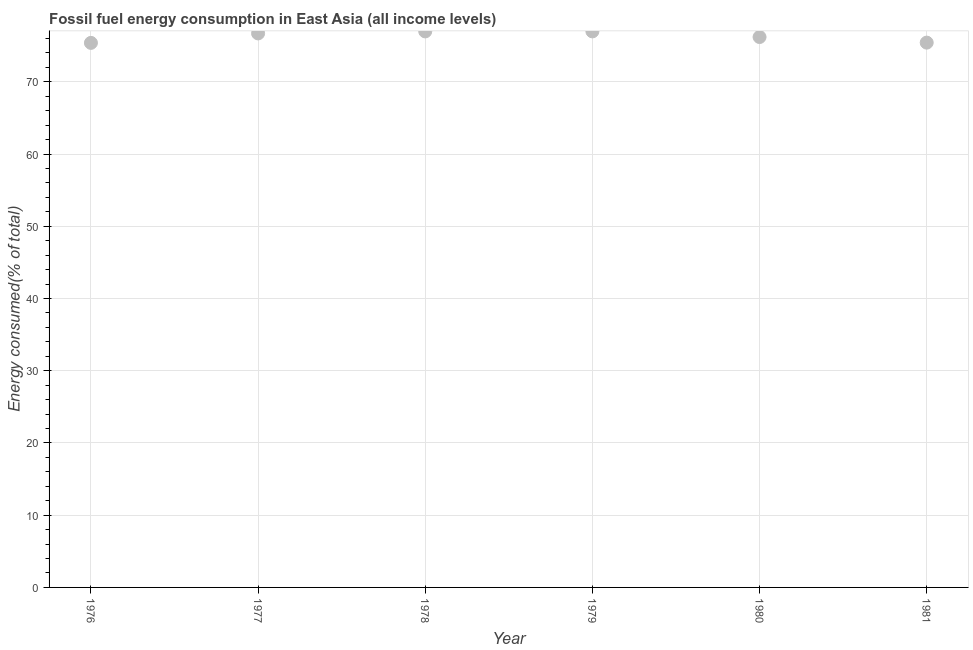What is the fossil fuel energy consumption in 1977?
Ensure brevity in your answer.  76.7. Across all years, what is the maximum fossil fuel energy consumption?
Ensure brevity in your answer.  76.98. Across all years, what is the minimum fossil fuel energy consumption?
Provide a succinct answer. 75.39. In which year was the fossil fuel energy consumption maximum?
Make the answer very short. 1979. In which year was the fossil fuel energy consumption minimum?
Your response must be concise. 1976. What is the sum of the fossil fuel energy consumption?
Give a very brief answer. 457.7. What is the difference between the fossil fuel energy consumption in 1976 and 1979?
Provide a succinct answer. -1.59. What is the average fossil fuel energy consumption per year?
Make the answer very short. 76.28. What is the median fossil fuel energy consumption?
Your answer should be very brief. 76.45. In how many years, is the fossil fuel energy consumption greater than 32 %?
Ensure brevity in your answer.  6. Do a majority of the years between 1977 and 1976 (inclusive) have fossil fuel energy consumption greater than 50 %?
Offer a terse response. No. What is the ratio of the fossil fuel energy consumption in 1977 to that in 1980?
Your response must be concise. 1.01. Is the fossil fuel energy consumption in 1979 less than that in 1980?
Keep it short and to the point. No. What is the difference between the highest and the second highest fossil fuel energy consumption?
Give a very brief answer. 0. What is the difference between the highest and the lowest fossil fuel energy consumption?
Your response must be concise. 1.59. In how many years, is the fossil fuel energy consumption greater than the average fossil fuel energy consumption taken over all years?
Offer a terse response. 3. Does the fossil fuel energy consumption monotonically increase over the years?
Give a very brief answer. No. How many years are there in the graph?
Offer a very short reply. 6. What is the difference between two consecutive major ticks on the Y-axis?
Your response must be concise. 10. Are the values on the major ticks of Y-axis written in scientific E-notation?
Ensure brevity in your answer.  No. What is the title of the graph?
Make the answer very short. Fossil fuel energy consumption in East Asia (all income levels). What is the label or title of the Y-axis?
Make the answer very short. Energy consumed(% of total). What is the Energy consumed(% of total) in 1976?
Your answer should be compact. 75.39. What is the Energy consumed(% of total) in 1977?
Provide a succinct answer. 76.7. What is the Energy consumed(% of total) in 1978?
Give a very brief answer. 76.98. What is the Energy consumed(% of total) in 1979?
Your answer should be very brief. 76.98. What is the Energy consumed(% of total) in 1980?
Ensure brevity in your answer.  76.2. What is the Energy consumed(% of total) in 1981?
Offer a terse response. 75.43. What is the difference between the Energy consumed(% of total) in 1976 and 1977?
Offer a very short reply. -1.31. What is the difference between the Energy consumed(% of total) in 1976 and 1978?
Provide a short and direct response. -1.59. What is the difference between the Energy consumed(% of total) in 1976 and 1979?
Ensure brevity in your answer.  -1.59. What is the difference between the Energy consumed(% of total) in 1976 and 1980?
Provide a succinct answer. -0.81. What is the difference between the Energy consumed(% of total) in 1976 and 1981?
Offer a terse response. -0.04. What is the difference between the Energy consumed(% of total) in 1977 and 1978?
Give a very brief answer. -0.28. What is the difference between the Energy consumed(% of total) in 1977 and 1979?
Provide a short and direct response. -0.28. What is the difference between the Energy consumed(% of total) in 1977 and 1980?
Provide a short and direct response. 0.5. What is the difference between the Energy consumed(% of total) in 1977 and 1981?
Make the answer very short. 1.27. What is the difference between the Energy consumed(% of total) in 1978 and 1979?
Ensure brevity in your answer.  -0. What is the difference between the Energy consumed(% of total) in 1978 and 1980?
Ensure brevity in your answer.  0.78. What is the difference between the Energy consumed(% of total) in 1978 and 1981?
Your answer should be very brief. 1.55. What is the difference between the Energy consumed(% of total) in 1979 and 1980?
Provide a succinct answer. 0.78. What is the difference between the Energy consumed(% of total) in 1979 and 1981?
Make the answer very short. 1.55. What is the difference between the Energy consumed(% of total) in 1980 and 1981?
Your answer should be very brief. 0.77. What is the ratio of the Energy consumed(% of total) in 1976 to that in 1977?
Give a very brief answer. 0.98. What is the ratio of the Energy consumed(% of total) in 1976 to that in 1978?
Ensure brevity in your answer.  0.98. What is the ratio of the Energy consumed(% of total) in 1976 to that in 1980?
Make the answer very short. 0.99. What is the ratio of the Energy consumed(% of total) in 1977 to that in 1978?
Your answer should be compact. 1. What is the ratio of the Energy consumed(% of total) in 1977 to that in 1979?
Keep it short and to the point. 1. What is the ratio of the Energy consumed(% of total) in 1977 to that in 1980?
Provide a succinct answer. 1.01. What is the ratio of the Energy consumed(% of total) in 1977 to that in 1981?
Your answer should be compact. 1.02. What is the ratio of the Energy consumed(% of total) in 1978 to that in 1979?
Your response must be concise. 1. What is the ratio of the Energy consumed(% of total) in 1978 to that in 1981?
Your response must be concise. 1.02. What is the ratio of the Energy consumed(% of total) in 1980 to that in 1981?
Ensure brevity in your answer.  1.01. 